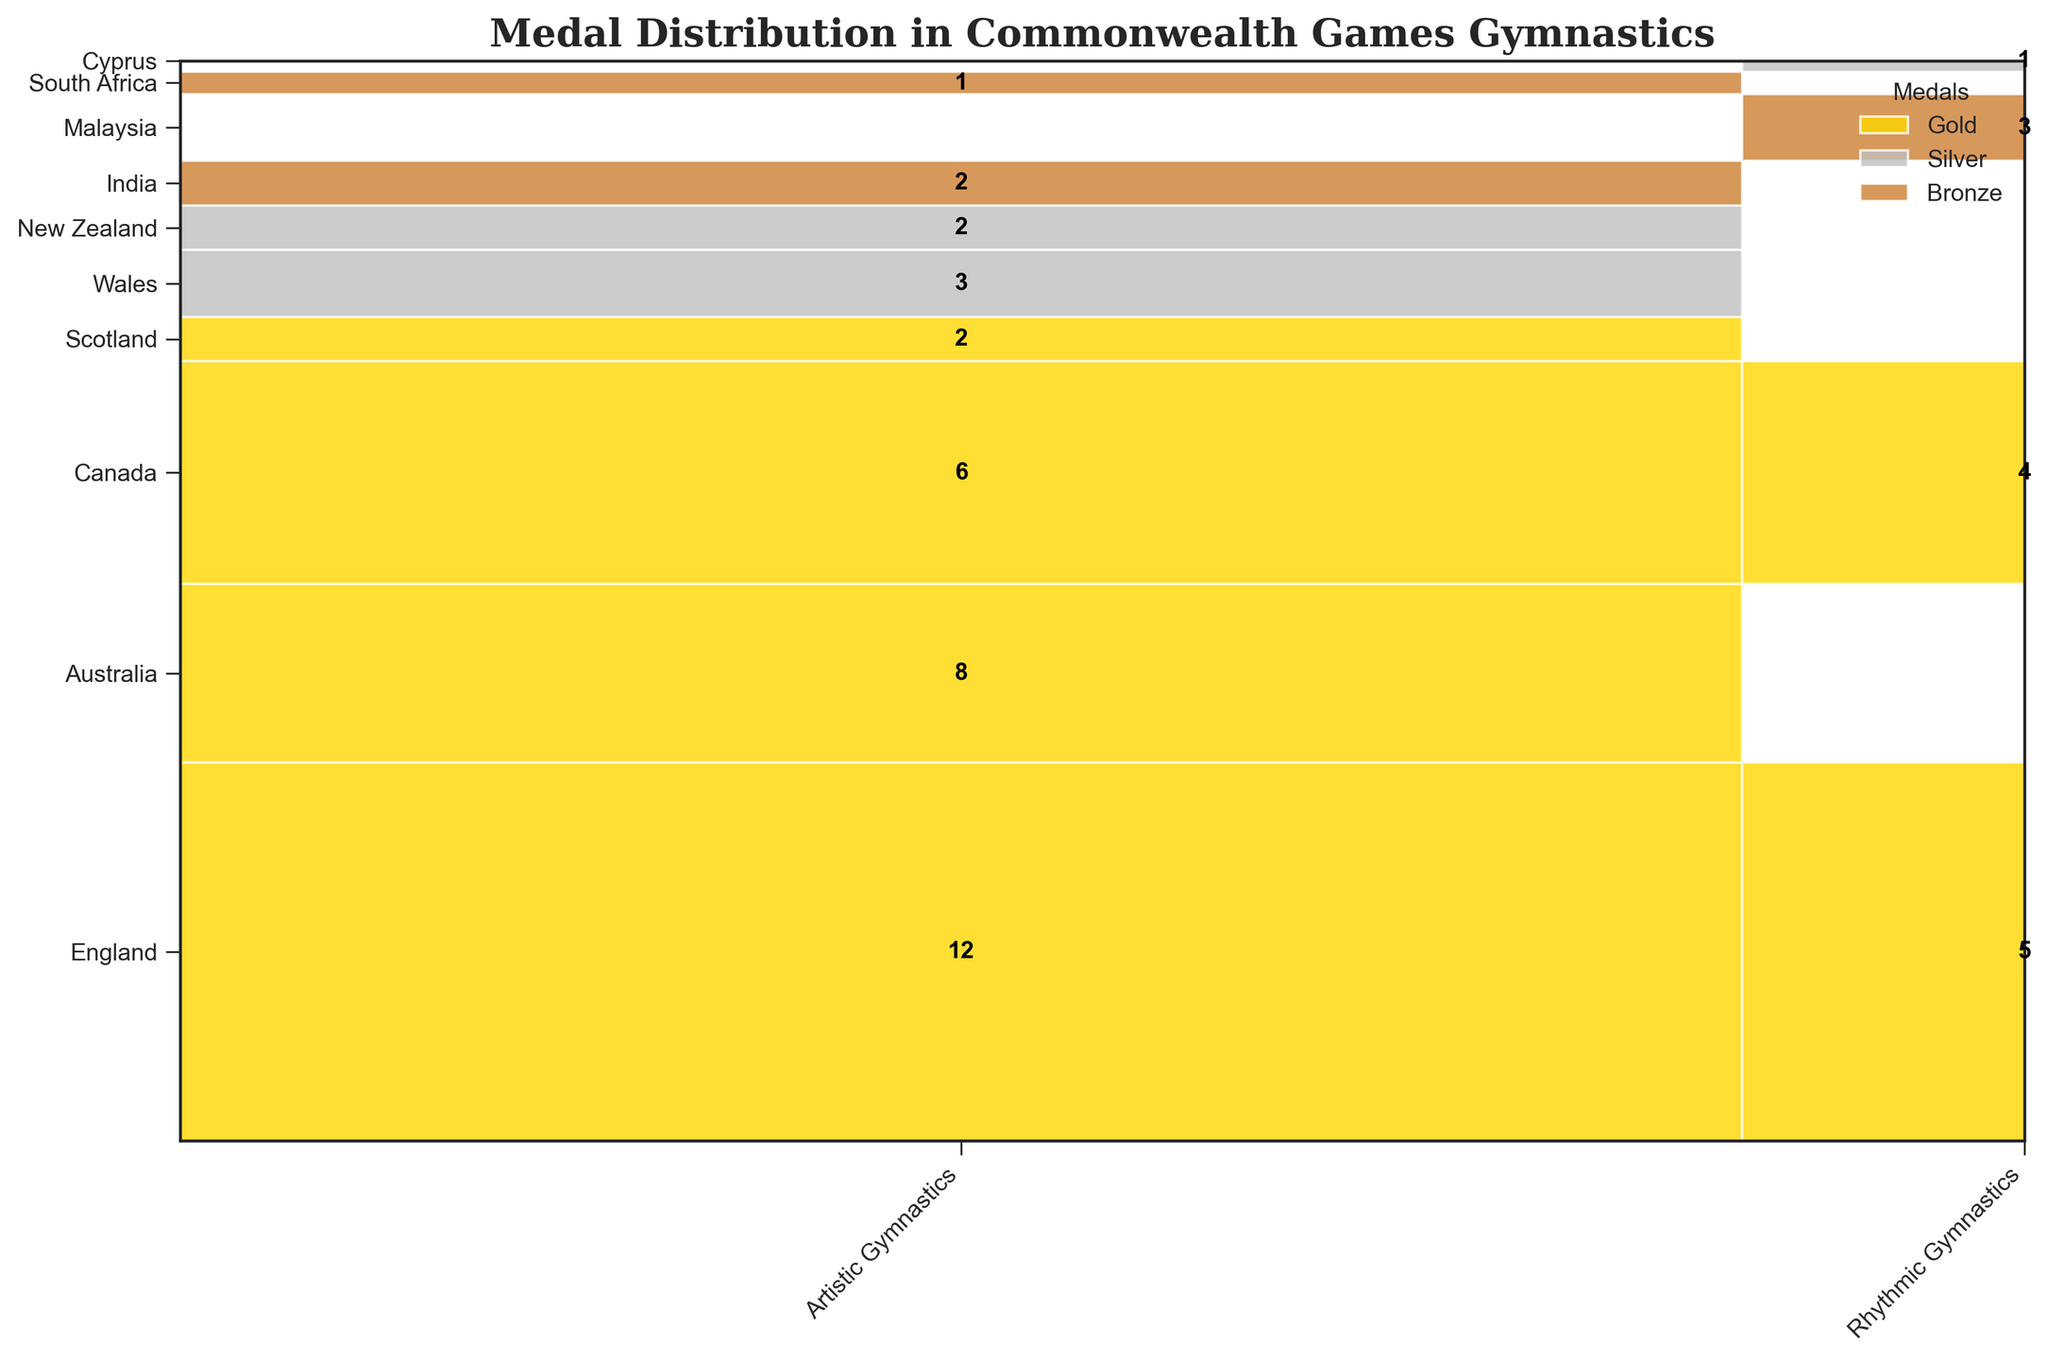what is the total number of gold medals in Artistic Gymnastics? To find the total number of gold medals in Artistic Gymnastics, sum up the counts for Australia, Canada, England, and Scotland. So, 12 (England) + 8 (Australia) + 6 (Canada) + 2 (Scotland) = 28.
Answer: 28 How many gold medals has Canada won? The plot shows that Canada has won 6 gold medals in Artistic Gymnastics and 4 gold medals in Rhythmic Gymnastics. Adding these together gives 6 + 4 = 10.
Answer: 10 Which country has the most silver medals in Artistic Gymnastics? By examining the countries and their medal counts, Wales has 3 silver medals in Artistic Gymnastics, while New Zealand has 2, so Wales has the most.
Answer: Wales Has any country won medals in both Artistic and Rhythmic Gymnastics? The plot can be checked for countries that have medals in both categories. Canada (gold medals in both) and England (gold medals in both) are the countries that have medals in both categories.
Answer: Canada, England Which sport has the higher number of medals overall? Sum all medal counts for both Artistic Gymnastics and Rhythmic Gymnastics. Artistic Gymnastics has 12 + 8 + 6 + 2 (gold) + 3 + 2 (silver) + 2 + 1 (bronze) = 36, while Rhythmic Gymnastics has 5 (gold) + 4 (gold) + 1 (silver) + 3 (bronze) = 13. Artistic Gymnastics has more medals.
Answer: Artistic Gymnastics What's the distribution of bronze medals in Rhythmic Gymnastics? The distribution is visible in the matrix of the mosaic plot. Malaysia has 3 bronze medals in Rhythmic Gymnastics.
Answer: Malaysia: 3 Which country has the least number of medals? By examining the total medal count for each country, South Africa has the least with only 1 bronze medal in Artistic Gymnastics.
Answer: South Africa What is the total number of medals won by England? England has won medals in both Artistic and Rhythmic Gymnastics. Summing up these values gives 12 (gold in Artistic) + 5 (gold in Rhythmic) = 17.
Answer: 17 